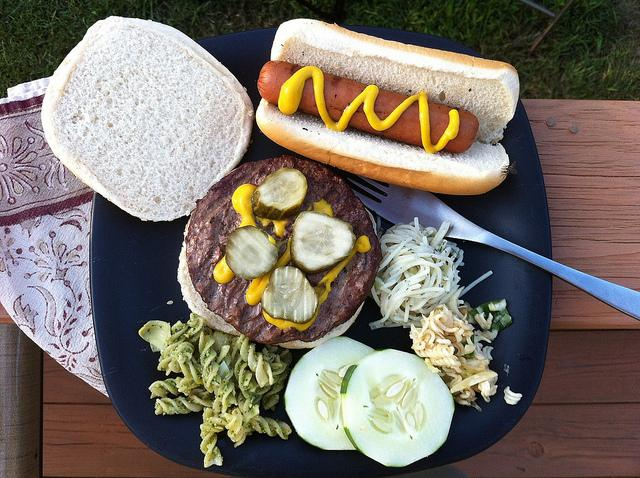How were the meats most likely cooked? Please explain your reasoning. bbq grill. They were grilled. 